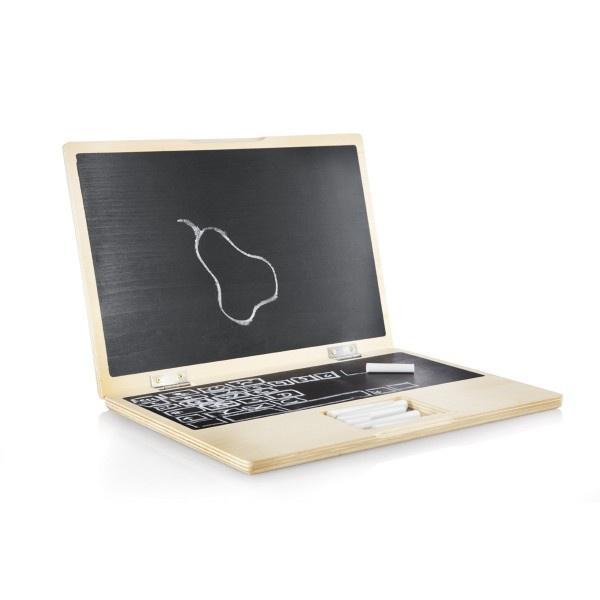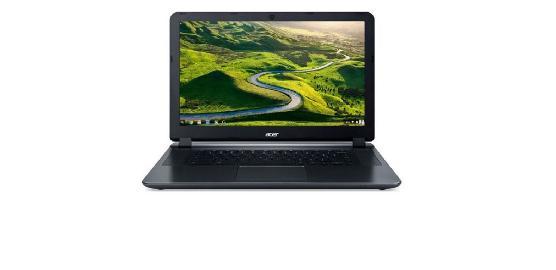The first image is the image on the left, the second image is the image on the right. Given the left and right images, does the statement "In the left image, there's a laptop by itself." hold true? Answer yes or no. Yes. The first image is the image on the left, the second image is the image on the right. For the images shown, is this caption "There is one cord visible." true? Answer yes or no. No. 